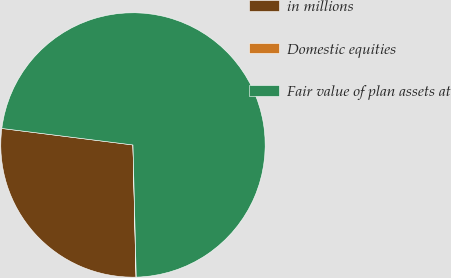Convert chart to OTSL. <chart><loc_0><loc_0><loc_500><loc_500><pie_chart><fcel>in millions<fcel>Domestic equities<fcel>Fair value of plan assets at<nl><fcel>27.36%<fcel>0.03%<fcel>72.62%<nl></chart> 